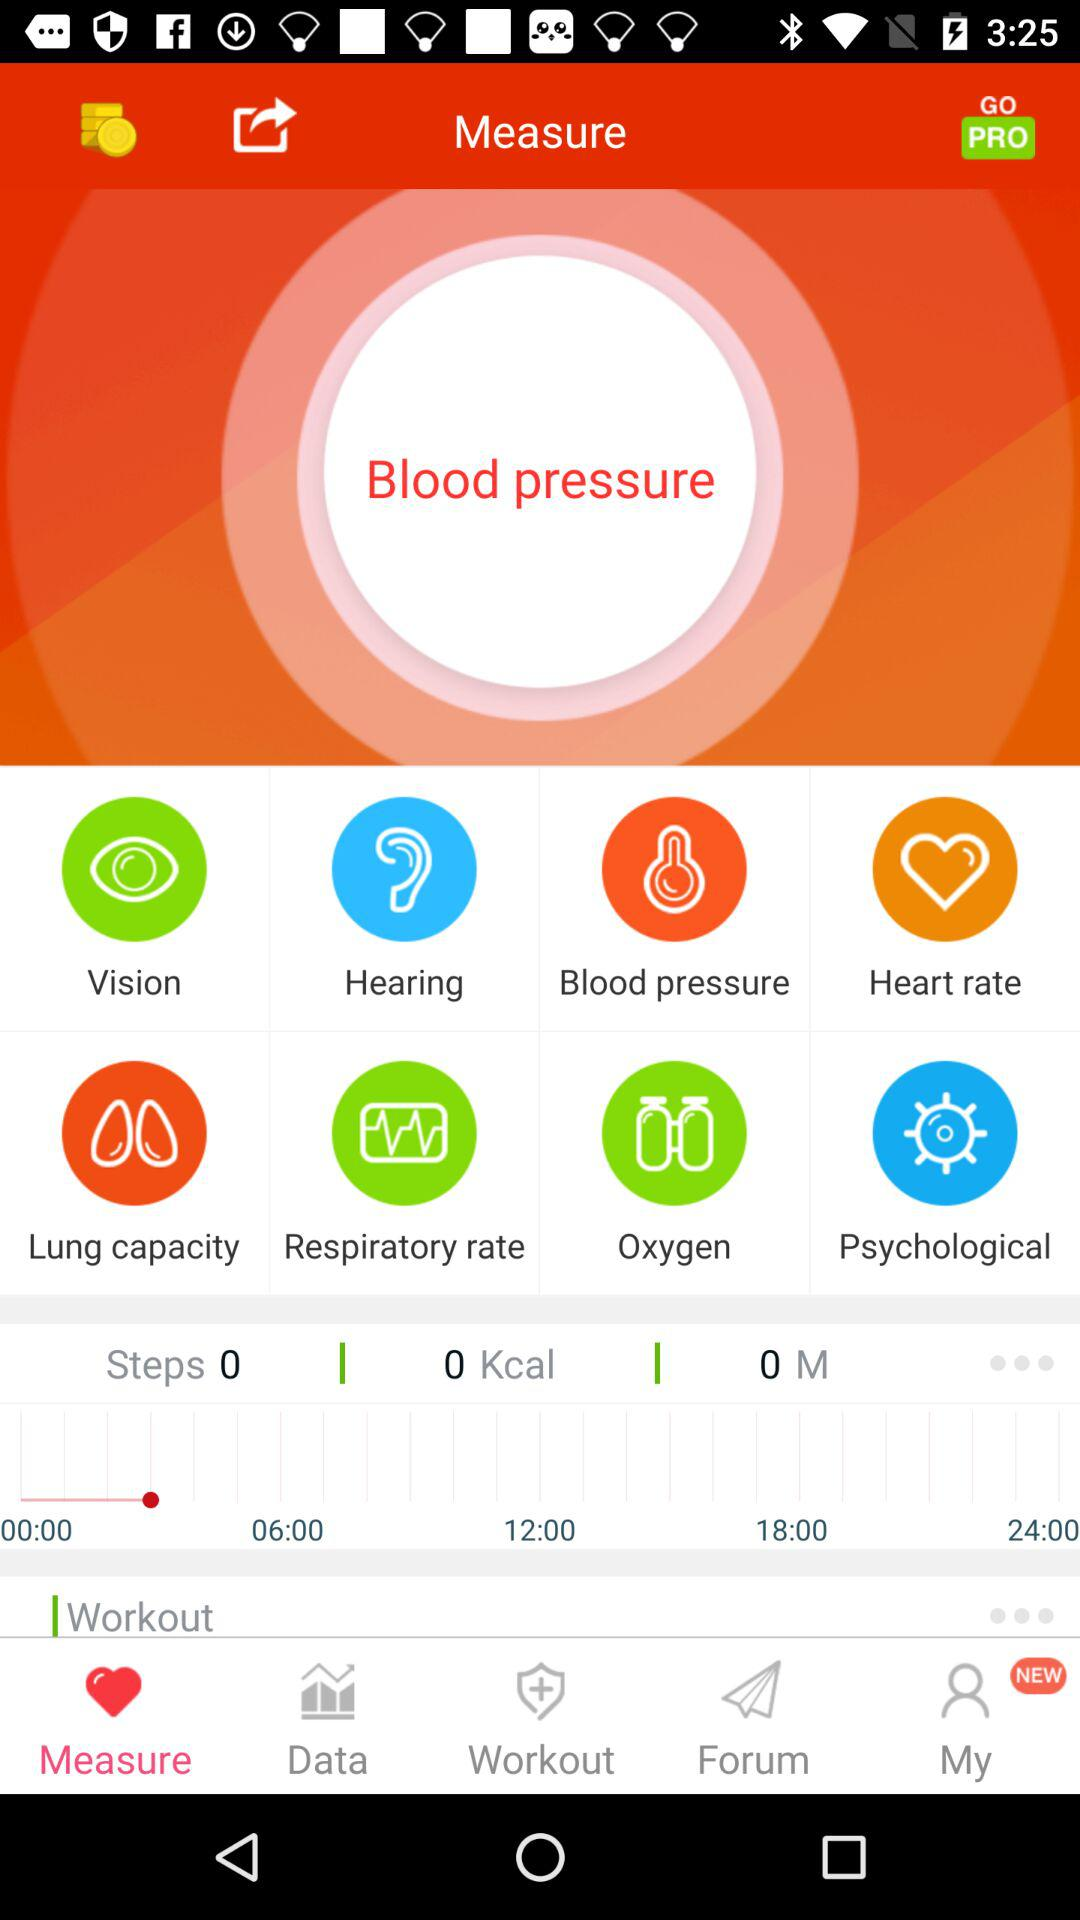What is the count of kcal? The count is 0. 